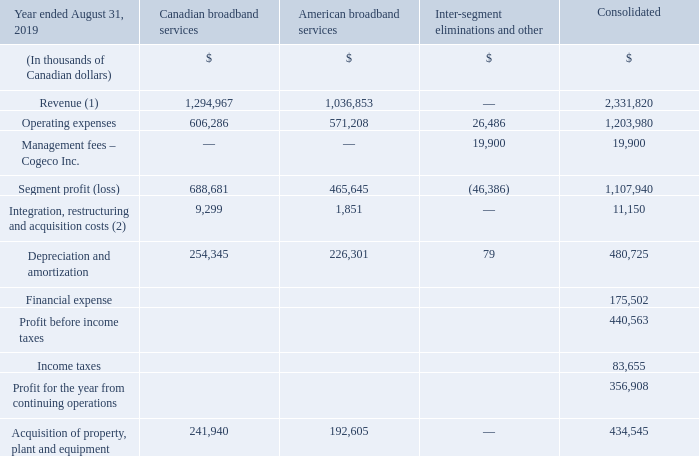The Corporation’s segment profit (loss) is reported in two operating segments: Canadian broadband services and American broadband services. The reporting structure reflects how the Corporation manages its business activities to make decisions about resources to be allocated to the segments and to assess their performance.
The Canadian and American broadband services segments provide a wide range of Internet, video and telephony services primarily to residential customers as well as business services across their coverage areas. The Canadian broadband services activities are carried out by Cogeco Connexion in the provinces of Québec and Ontario and the American broadband services activities are carried out by Atlantic Broadband in 11 states: Connecticut, Delaware, Florida, Maine, Maryland, New Hampshire, New York, Pennsylvania, South Carolina, Virginia and West Virginia.
The previously reported Business ICT services segment, comprised of the Cogeco Peer 1 operations, is now reported in discontinued operations following the sale on April 30, 2019 of the Cogeco Peer 1 subsidiary. Information about the discontinued segment is provided in Note 8.
The Corporation and its chief operating decision maker assess the performance of each operating segment based on its segment profit (loss), which is equal to revenue less operating expenses. The other expenses, except for management fees, financial expense and income taxes, are reported by segment solely for external reporting purposes.
(1) Revenue by geographic market includes $1,294,967 in Canada and $1,036,853 in the United States. (2) Comprised of restructuring costs within the Canadian broadband services segment and acquisition and integration costs related to the FiberLight network acquisition in the American broadband services segment.
Where is the activities of Canadian broadband services carried out? Québec and ontario. Where is the activities of American broadband services carried out? 11 states: connecticut, delaware, florida, maine, maryland, new hampshire, new york, pennsylvania, south carolina, virginia and west virginia. What are the services provided by Canadian and American broadband? A wide range of internet, video and telephony services primarily to residential customers as well as business services across their coverage areas. What is the average Revenue between Canadian and American broadband services for year ended August 31, 2019?
Answer scale should be: thousand. (1,294,967+1,036,853)/ 2
Answer: 1165910. What are the average Operating expenses from Canadian and American broadband services for year ended August 31, 2019?
Answer scale should be: thousand. (606,286+571,208 ) / 2
Answer: 588747. What is the average Integration, restructuring and acquisition costs from Canadian and American broadband services for year ended August 31, 2019?
Answer scale should be: thousand. (9,299+1,851) / 2
Answer: 5575. 